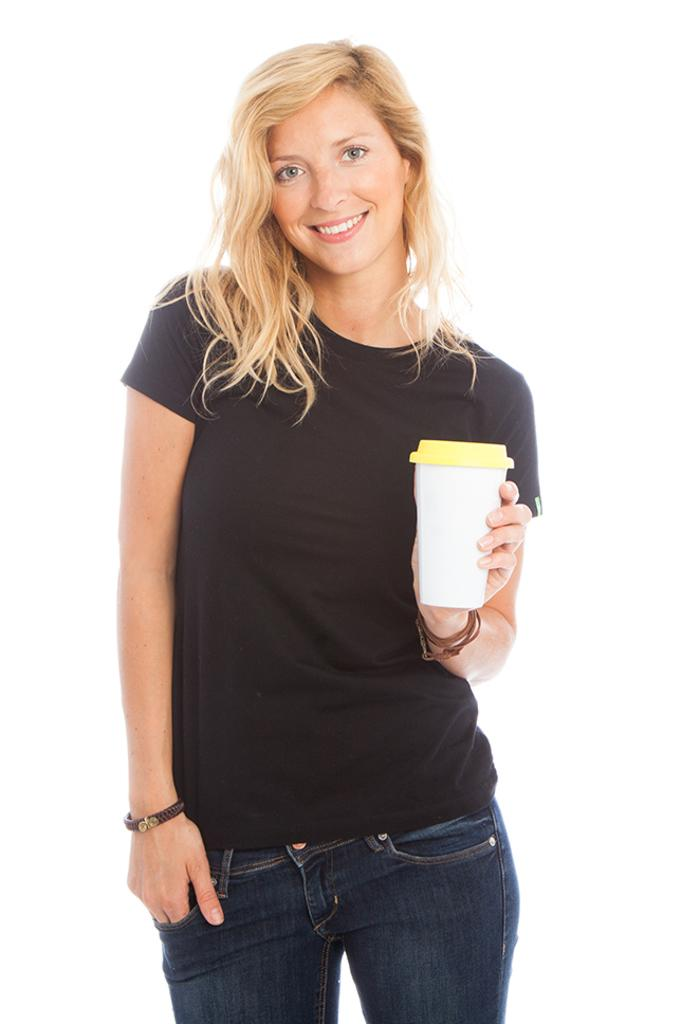Who is the main subject in the foreground of the picture? There is a woman in the foreground of the picture. What is the woman wearing? The woman is wearing a black T-shirt. What is the woman holding in her hand? The woman is holding a tin in her hand. What can be observed about the background of the image? The background of the image is dark. What type of clover can be seen growing near the woman's feet in the image? There is no clover visible in the image; it only features a woman wearing a black T-shirt and holding a tin in her hand. 